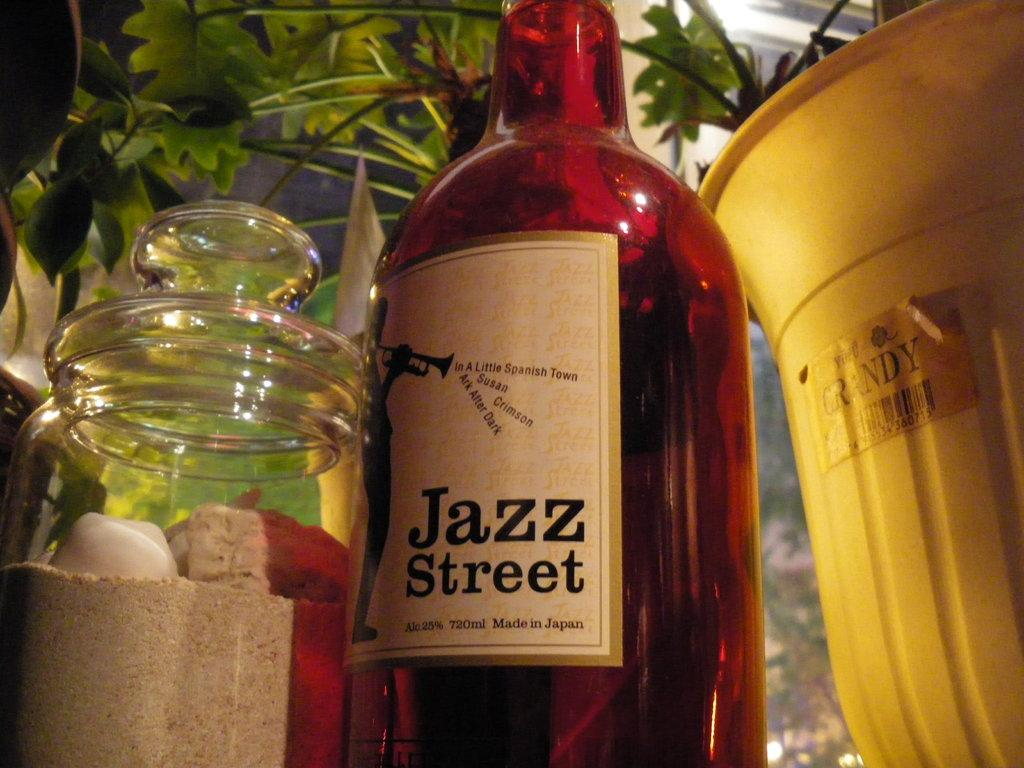What type of container is present in the image? There is a bottle and a glass jar in the image. What color is the object in the image? There is a yellow color object in the image. What type of living organisms can be seen in the image? There are plants around in the image. Is your sister participating in the competition shown in the image? There is no mention of a sister or a competition in the image, so it cannot be determined from the image. 